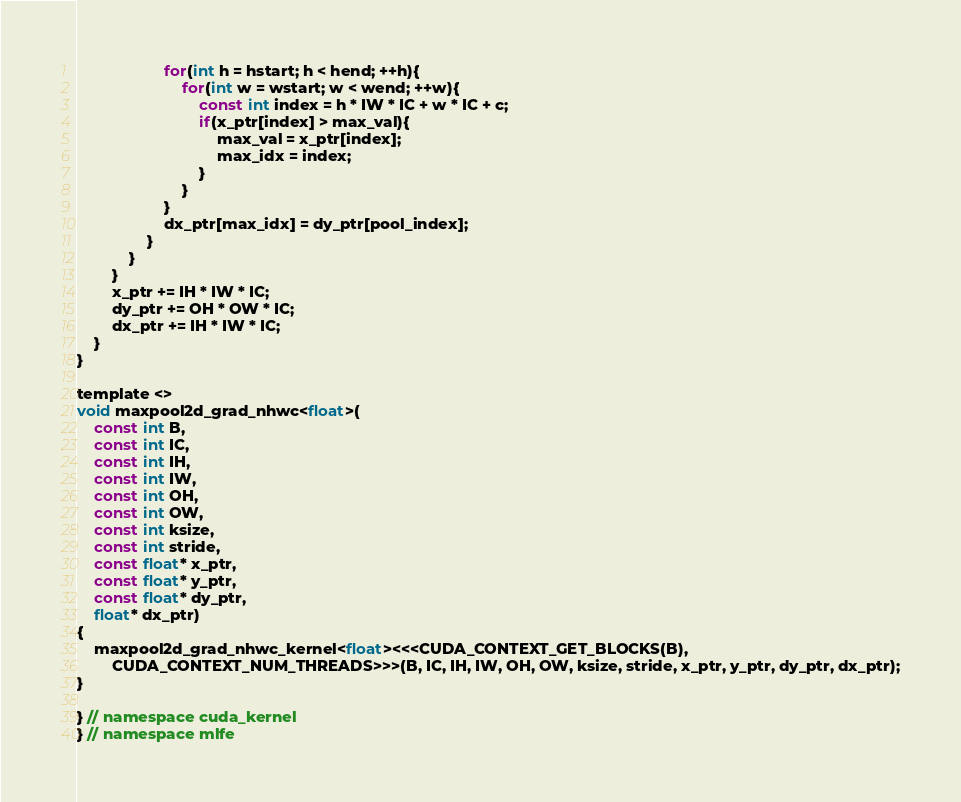<code> <loc_0><loc_0><loc_500><loc_500><_Cuda_>                    for(int h = hstart; h < hend; ++h){
                        for(int w = wstart; w < wend; ++w){
                            const int index = h * IW * IC + w * IC + c;
                            if(x_ptr[index] > max_val){
                                max_val = x_ptr[index];
                                max_idx = index;
                            }
                        }
                    }
                    dx_ptr[max_idx] = dy_ptr[pool_index];
                }
            }
        }
        x_ptr += IH * IW * IC;
        dy_ptr += OH * OW * IC;
        dx_ptr += IH * IW * IC;
    }
}

template <>
void maxpool2d_grad_nhwc<float>(
    const int B,
    const int IC,
    const int IH,
    const int IW,
    const int OH,
    const int OW,
    const int ksize,
    const int stride,
    const float* x_ptr,
    const float* y_ptr,
    const float* dy_ptr,
    float* dx_ptr)
{
    maxpool2d_grad_nhwc_kernel<float><<<CUDA_CONTEXT_GET_BLOCKS(B),
        CUDA_CONTEXT_NUM_THREADS>>>(B, IC, IH, IW, OH, OW, ksize, stride, x_ptr, y_ptr, dy_ptr, dx_ptr);
}

} // namespace cuda_kernel
} // namespace mlfe
</code> 